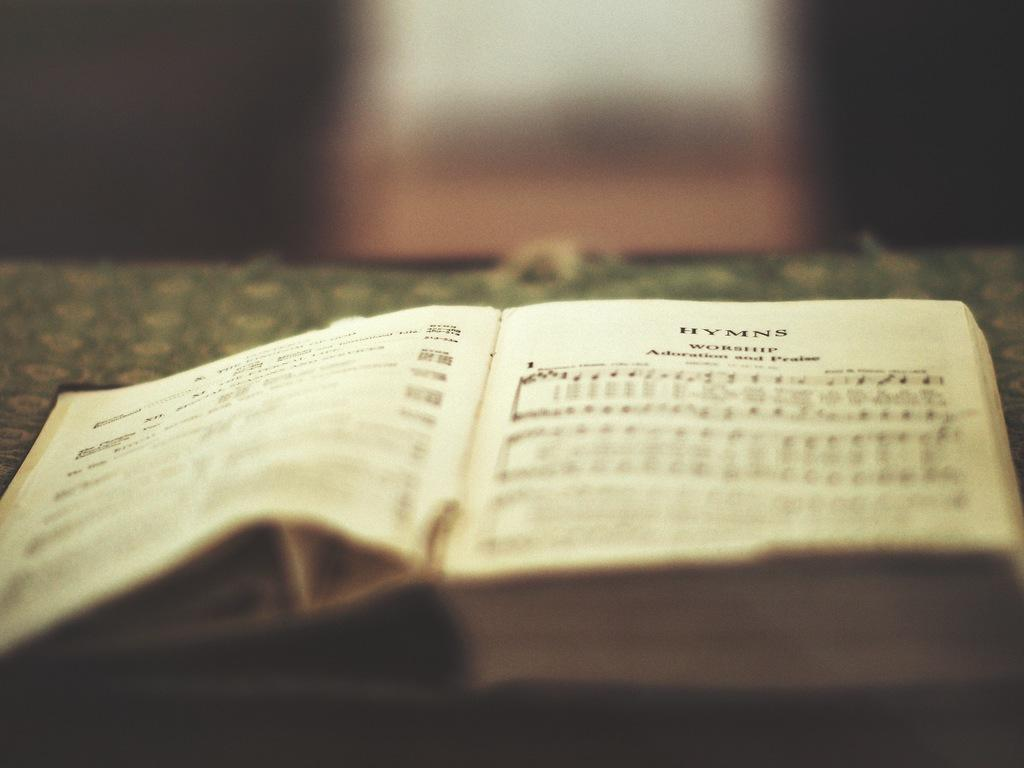<image>
Summarize the visual content of the image. A book of hymns on Worship Adoration and Praise 